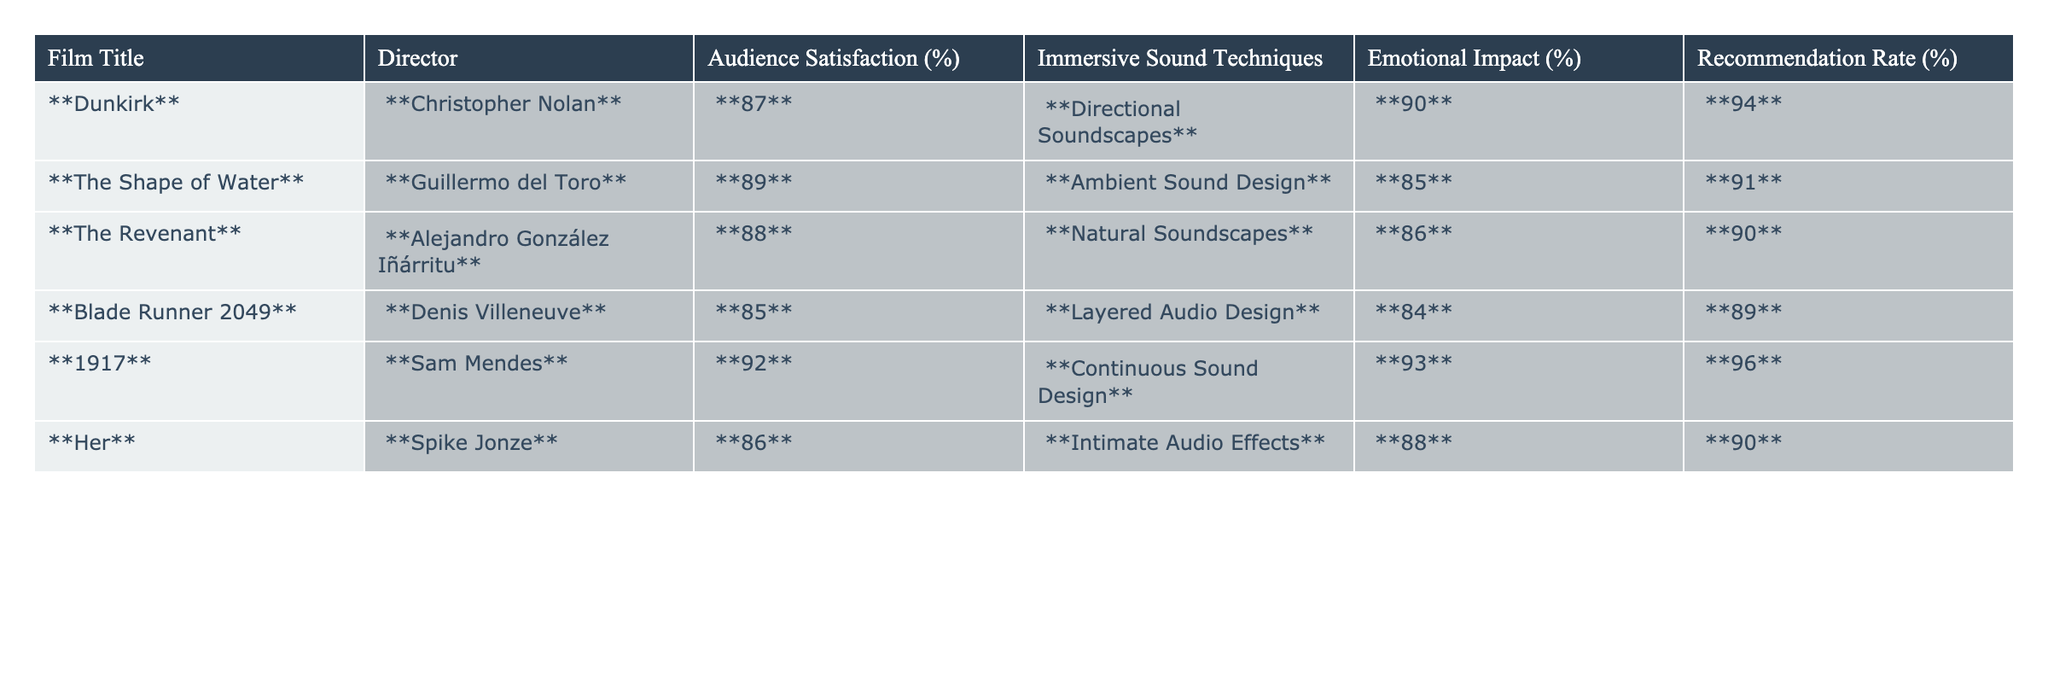What is the audience satisfaction percentage for "1917"? The table shows that the audience satisfaction percentage for "1917" is 92%.
Answer: 92% Which film has the highest recommendation rate? By inspecting the table, "1917" has the highest recommendation rate at 96%.
Answer: 96% What is the average emotional impact percentage across all films? To find the average, we sum the emotional impact percentages (90 + 85 + 86 + 84 + 93 + 88 = 516) and divide by 6 (the number of films). So, the average is 516 / 6 = 86.
Answer: 86% Is it true that "Dunkirk" has a higher audience satisfaction percentage than "Blade Runner 2049"? Yes, "Dunkirk" has a satisfaction percentage of 87%, which is higher than "Blade Runner 2049" at 85%.
Answer: Yes What is the difference in audience satisfaction percentage between "The Shape of Water" and "Her"? "The Shape of Water" has an audience satisfaction of 89%, while "Her" has 86%. The difference is 89 - 86 = 3%.
Answer: 3% If we rank the films by emotional impact percentage, which film comes fourth? The emotional impact percentages are sorted: "Dunkirk" (90), "1917" (93), "The Revenant" (86), "The Shape of Water" (85), "Her" (88), "Blade Runner 2049" (84). The fourth in rank is "Her."
Answer: Her What is the relationship between immersive sound techniques and audience satisfaction in these films? The table suggests that films using immersive sound techniques like "Continuous Sound Design" in "1917" correlate with the highest audience satisfaction of 92%. This points to a positive relationship between sound design and audience enjoyment.
Answer: Positive relationship How many films have an emotional impact percentage greater than or equal to 88%? By examining the emotional impact percentages (90, 85, 86, 84, 93, 88), four films ("Dunkirk," "The Revenant," "1917," and "Her") have an emotional impact percentage of 88% or more.
Answer: 4 